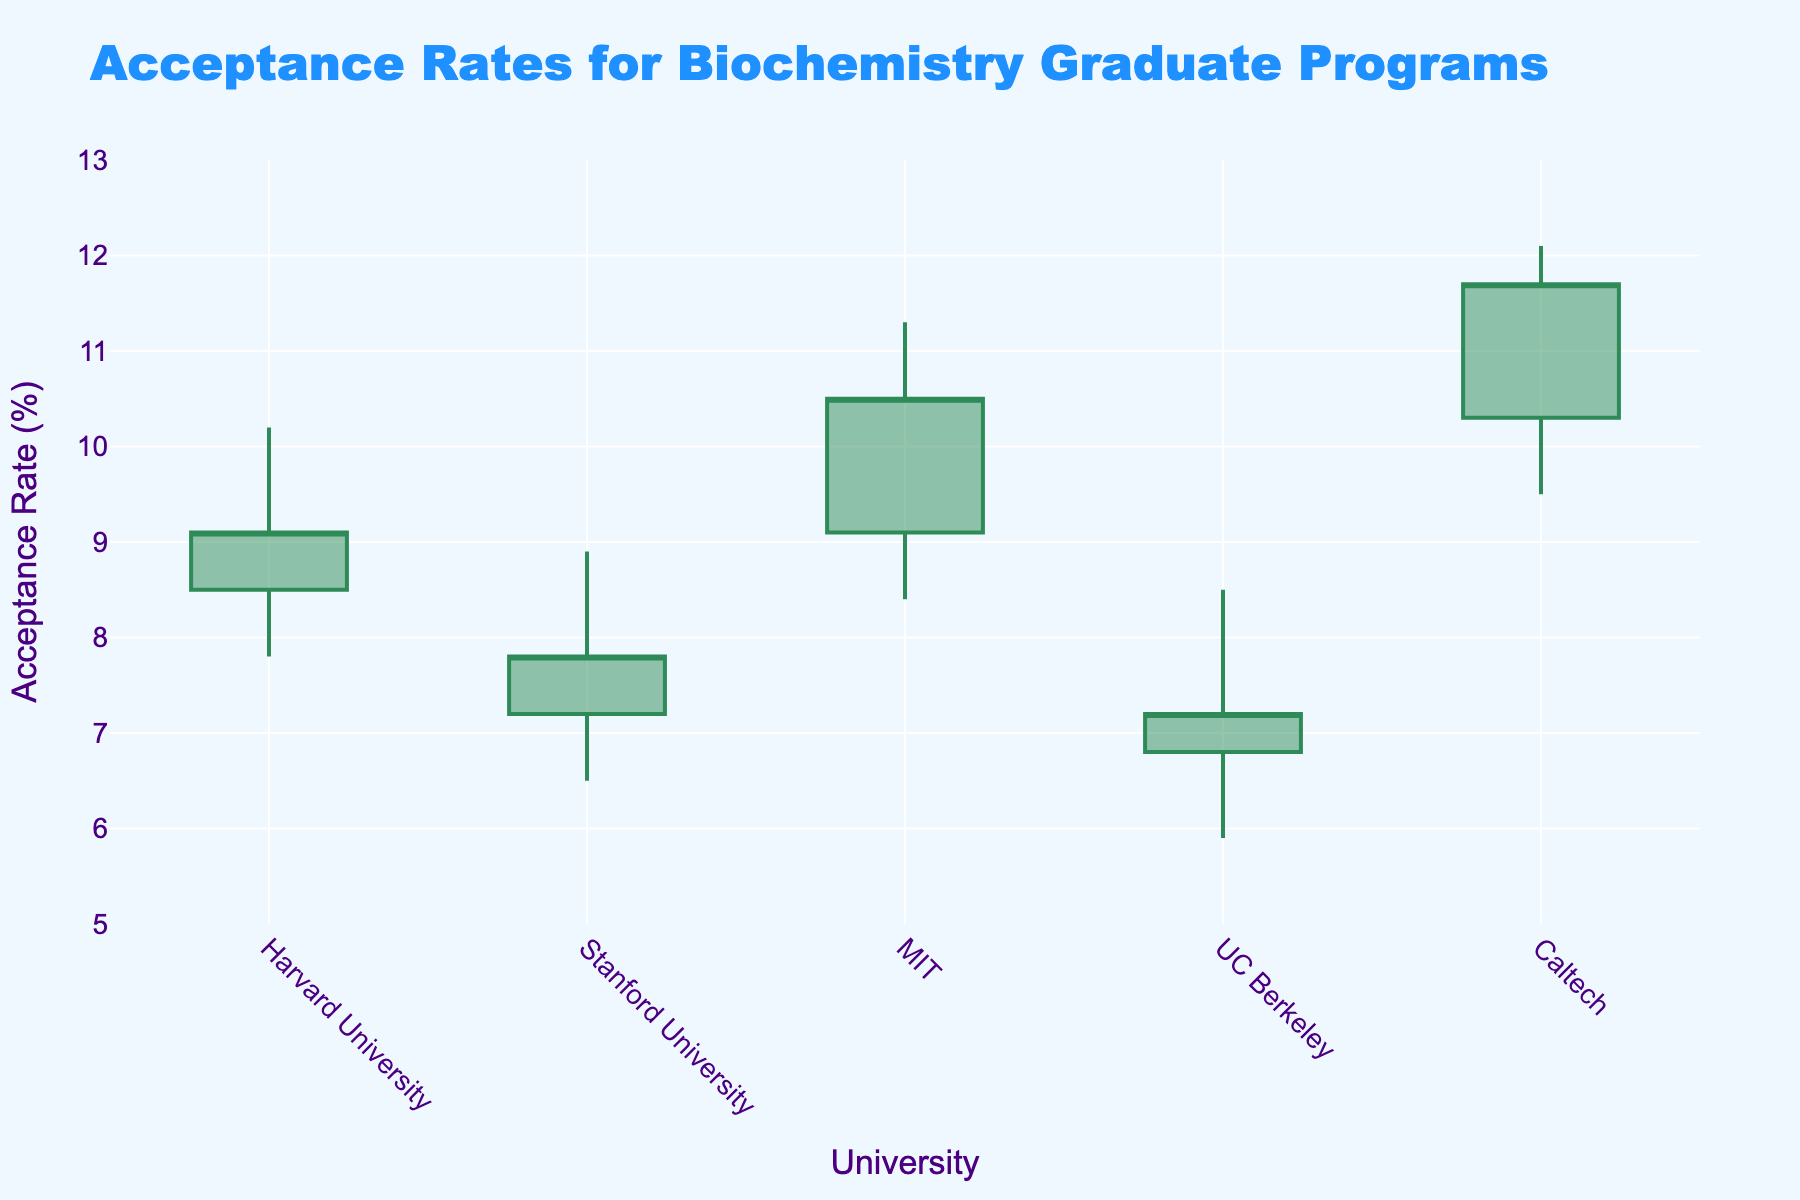What's the title of the chart? The title of the chart is displayed at the top of the figure.
Answer: Acceptance Rates for Biochemistry Graduate Programs How many universities are shown in the plot? Each candlestick corresponds to a different university. By counting the number of candlesticks, we can determine the number of universities.
Answer: 5 Which university had the highest acceptance rate in 2020 and what was it? Look for the data point labeled "MIT" and check the highest (High) value shown for that candlestick.
Answer: 11.3% Which year saw Caltech having its lowest acceptance rate, and what was it? Identify the candlestick labeled "Caltech" and find the lowest (Low) value for that year.
Answer: 2022, 9.5% What is the acceptance rate range for UC Berkeley in 2021? For the candle labeled "UC Berkeley," the range is determined by the difference between the highest (High) and lowest (Low) values. Calculate the range: 8.5 - 5.9.
Answer: 2.6% Compare the acceptance rate range for Harvard University in 2018 and Stanford University in 2019; which university had a wider range? Calculate the range for both Harvard and Stanford by subtracting the Low value from the High value for each and compare: Harvard (10.2 - 7.8) and Stanford (8.9 - 6.5).
Answer: Harvard University Which university had the most significant increase in acceptance rate from its lowest to its closing rate and how much was the increase? Look at the Low and Close values for each university and calculate the increase (Close - Low). Identify which has the largest difference.
Answer: Caltech, 2.2% Was the acceptance rate trend for Stanford University in 2019 increasing or decreasing throughout the year? Compare the Open and Close values for Stanford; if the Close is lower than the Open, the trend is decreasing.
Answer: Decreasing Which university started with the highest acceptance rate and how much was it? Check the Open value for each university and identify the highest one.
Answer: Caltech, 10.3% What is the median closing acceptance rate for all universities shown in the chart? List all the closing acceptance rates and find the median value: 9.1, 7.8, 10.5, 7.2, 11.7. The median is the middle value when the numbers are in order.
Answer: 9.1 